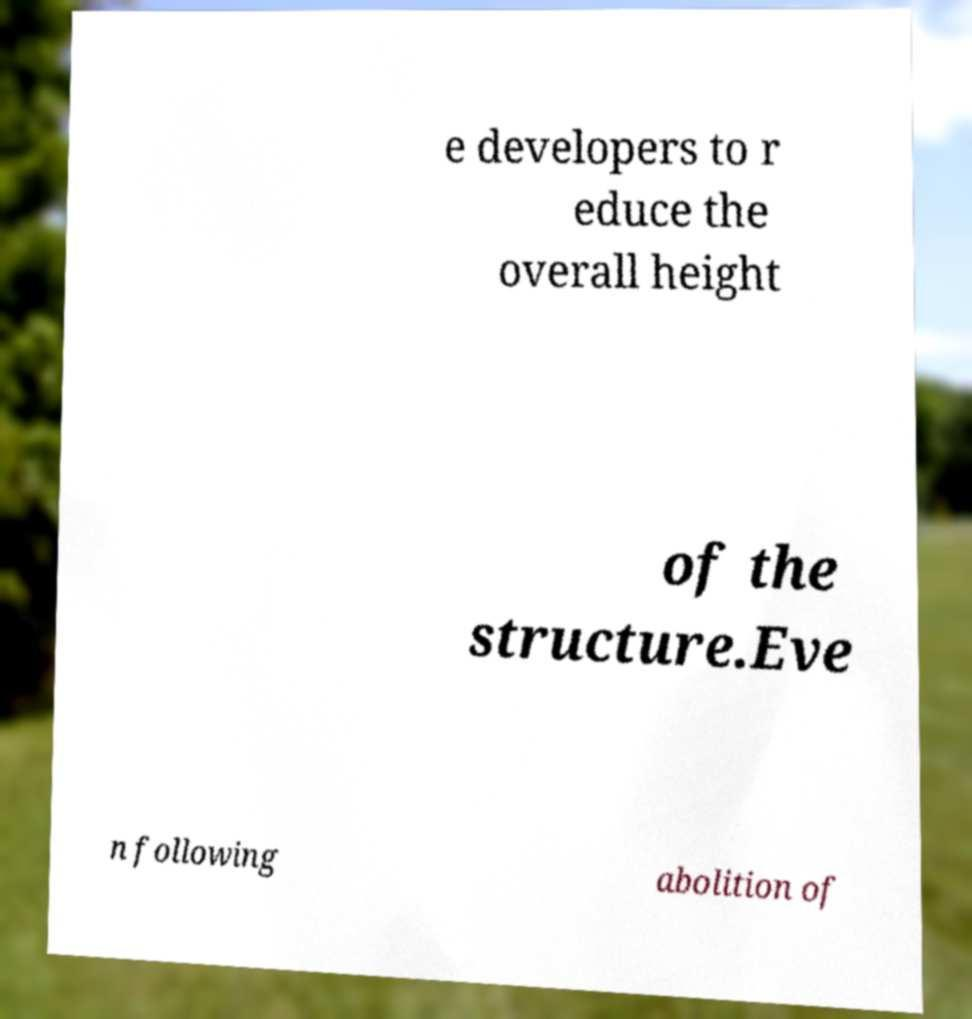Could you assist in decoding the text presented in this image and type it out clearly? e developers to r educe the overall height of the structure.Eve n following abolition of 